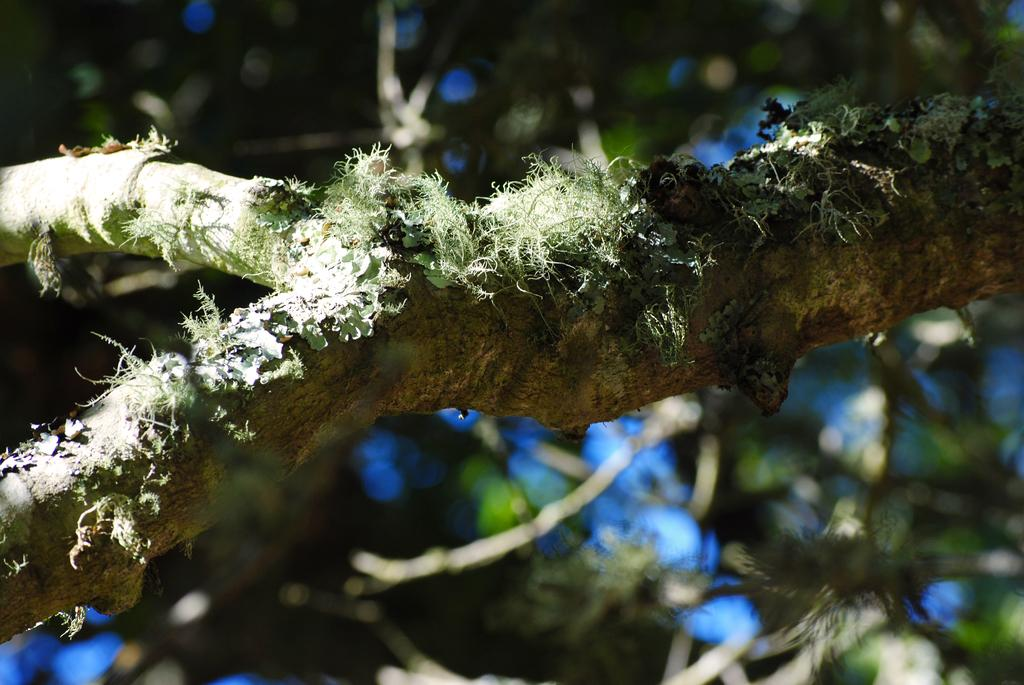What type of vegetation can be seen in the image? There are branches and leaves in the image. Can you describe the background of the image? The background of the image is blurry. Can you hear the kitten crying in the image? There is no kitten present in the image, so it cannot be heard crying. 